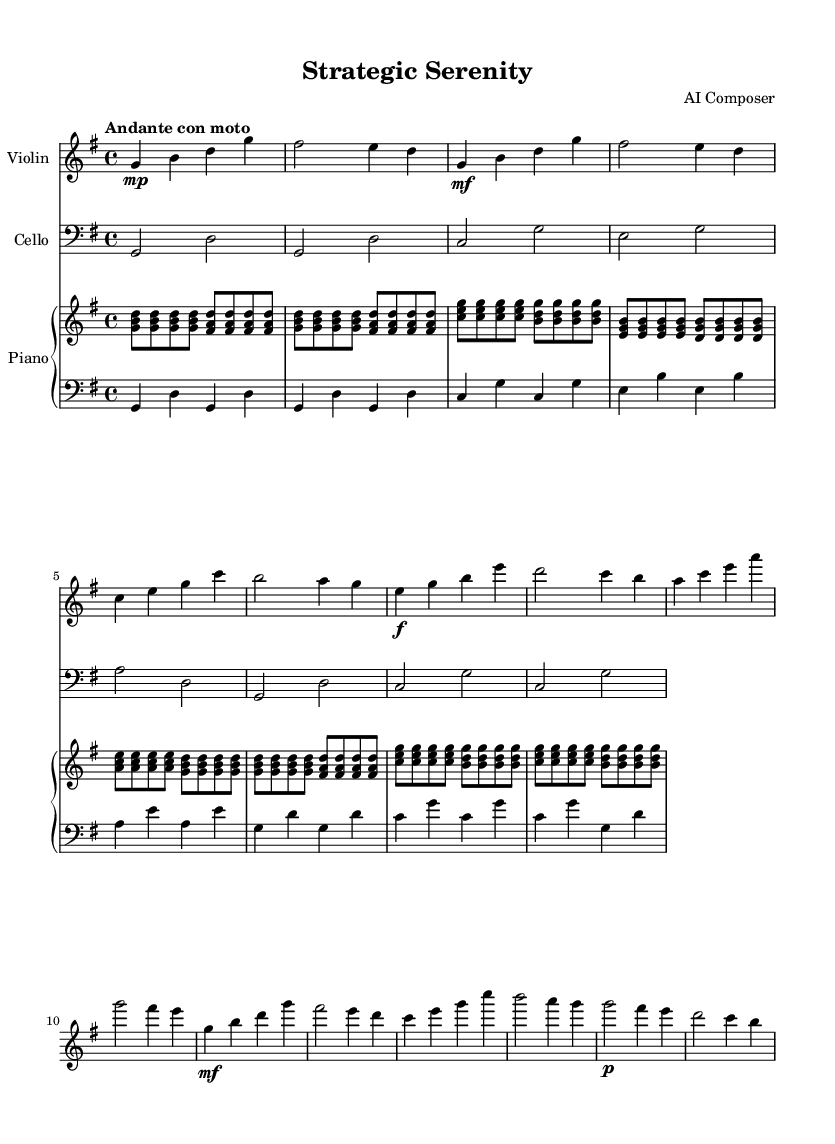What is the key signature of this music? The key signature indicates the key of G major, which has one sharp (F#).
Answer: G major What is the time signature of this music? The time signature is indicated at the beginning of the score, showing that it is in 4/4 time.
Answer: 4/4 What is the tempo marking of this music? The tempo marking at the start of the piece is "Andante con moto," which indicates a moderate tempo with a slight increase in speed.
Answer: Andante con moto How many sections does the music have? Upon analyzing the structure, the music features distinct sections labeled as Intro, A, B, A', and Coda, totaling five sections.
Answer: Five Which instrument plays the highest notes? The violin part consistently plays the highest notes throughout the piece when compared to the cello and piano parts.
Answer: Violin What dynamics are indicated in section B for the violin? In section B, the violin has a forte (f) marking, indicating that the music should be played loudly.
Answer: Forte What is the relationship between sections A and A'? Sections A and A' are identical in melody and rhythm, with A' often serving as a reprise or variation of A, allowing for a sense of familiarity.
Answer: Identical 